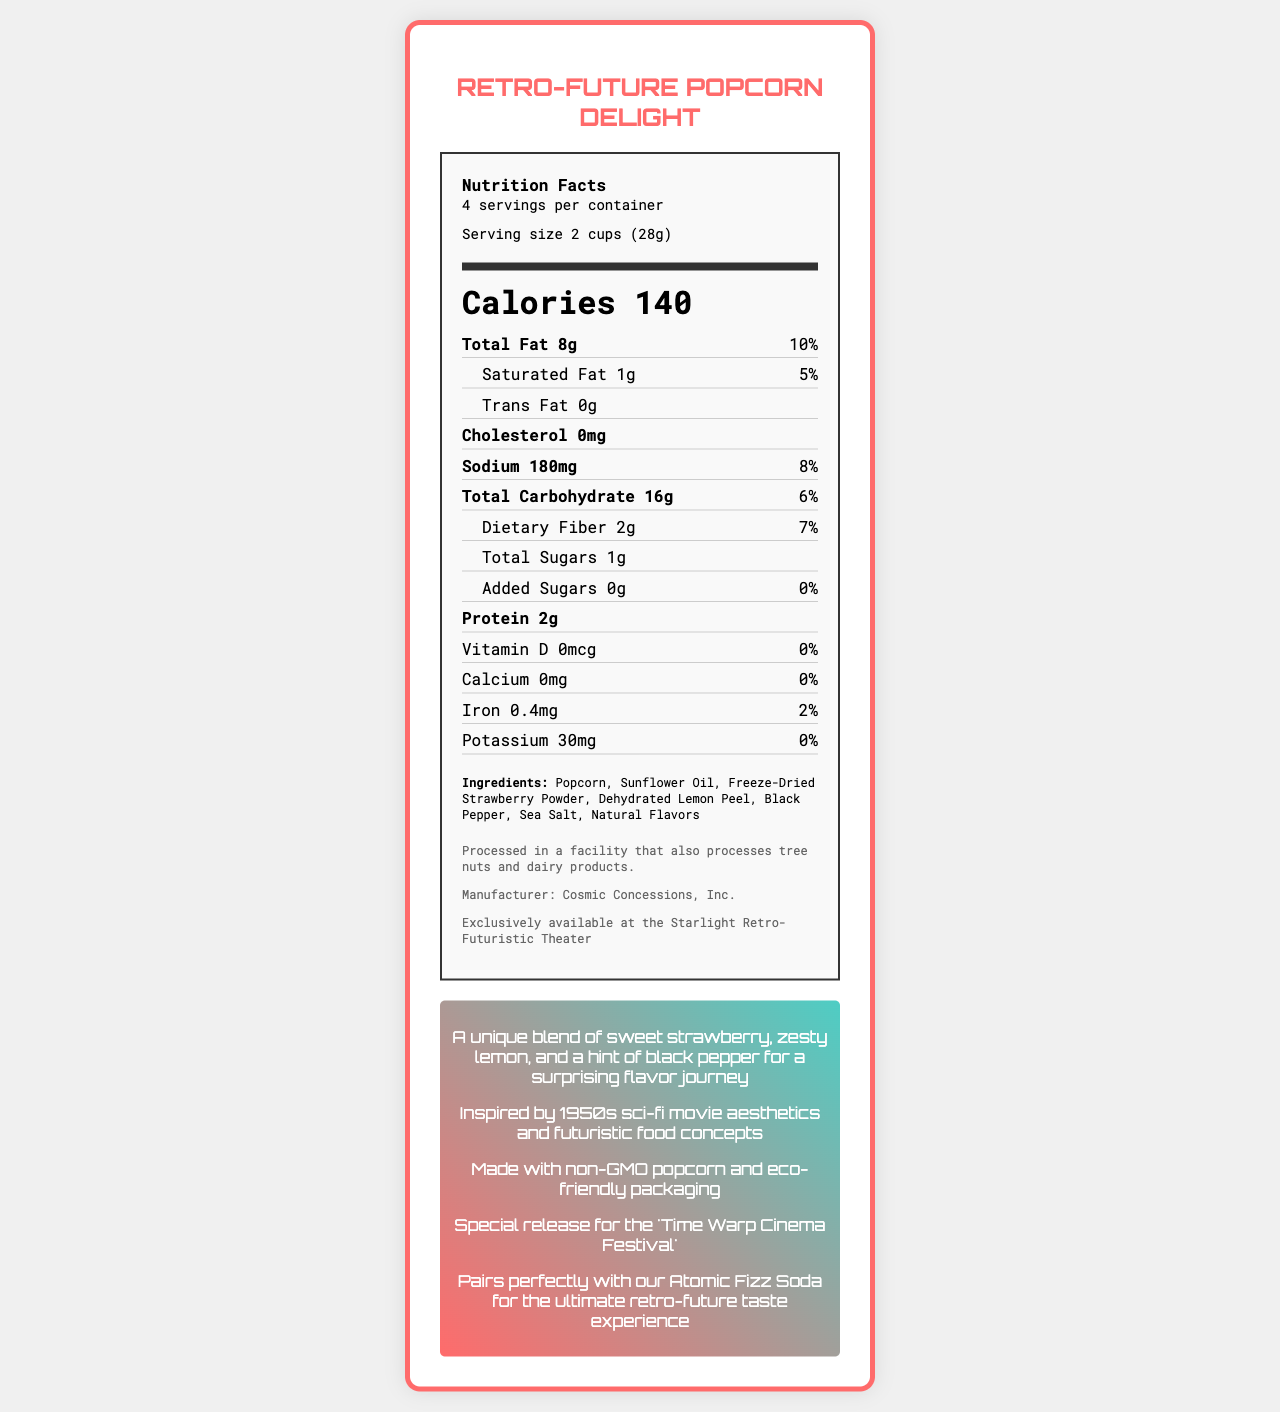What is the serving size of Retro-Future Popcorn Delight? The serving size is explicitly mentioned in the label under the "Serving size" section as "2 cups (28g)".
Answer: 2 cups (28g) What is the total calorie count per serving for the Retro-Future Popcorn Delight? The total calorie count is displayed prominently in the "Calories" section, which is 140 calories per serving.
Answer: 140 calories List three main ingredients of Retro-Future Popcorn Delight. The ingredients list in the document includes these as the first three ingredients.
Answer: Popcorn, Sunflower Oil, Freeze-Dried Strawberry Powder How many servings are in each container of Retro-Future Popcorn Delight? The document states "4 servings per container".
Answer: 4 What is the amount of sodium per serving? In the "Sodium" section of the label, it states that there are 180mg of sodium per serving.
Answer: 180mg Which nutrient has a daily value percentage of 5%? 
A. Vitamin D 
B. Saturated Fat 
C. Potassium The saturated fat in the "Saturated Fat" section has a daily value of 5%.
Answer: B What company manufactures Retro-Future Popcorn Delight? 
1. Galactic Snacks Co. 
2. Cosmic Concessions, Inc. 
3. Astro Treats Ltd. 
4. Interstellar Munchies Corp. The manufacturer is listed as Cosmic Concessions, Inc.
Answer: 2 Is there any cholesterol in Retro-Future Popcorn Delight? The nutrition facts explicitly note that there is 0mg of cholesterol.
Answer: No Describe the overall design inspiration and additional information provided for Retro-Future Popcorn Delight. The document provides details on the unique flavor profile, design inspiration, sustainability note, and pairing suggestion in the "retro-future" section, as well as the allergen information and manufacturer details.
Answer: The document describes Retro-Future Popcorn Delight as drawing inspiration from 1950s sci-fi movie aesthetics and futuristic food concepts. It highlights that the popcorn is made with non-GMO ingredients and packaged in eco-friendly, Art Deco-inspired buckets. It also notes the limited edition release for the 'Time Warp Cinema Festival' and suggests pairing the popcorn with Atomic Fizz Soda. What is the daily value percentage of dietary fiber per serving? The dietary fiber section shows that the daily value is 7%.
Answer: 7% How much protein is in one serving of Retro-Future Popcorn Delight? The protein content per serving is noted as 2 grams.
Answer: 2g How would you summarize the flavor profile of Retro-Future Popcorn Delight? The document explicitly describes the popcorn's flavor profile in this manner.
Answer: A unique blend of sweet strawberry, zesty lemon, and a hint of black pepper. Who is this product exclusively available to? The document mentions that Retro-Future Popcorn Delight is exclusively available at the Starlight Retro-Futuristic Theater.
Answer: Visitors to the Starlight Retro-Futuristic Theater What is the total fat percentage in Retro-Future Popcorn Delight? The total fat section lists the percentage as 10%.
Answer: 10% of the daily value What kind of packaging does Retro-Future Popcorn Delight come in? This is specifically mentioned in the packaging section of the document.
Answer: Recyclable Art Deco-inspired popcorn bucket Are there any tree nuts in Retro-Future Popcorn Delight? The document states it is processed in a facility that also processes tree nuts, but it does not confirm the presence of tree nuts in the product itself.
Answer: Cannot be determined 